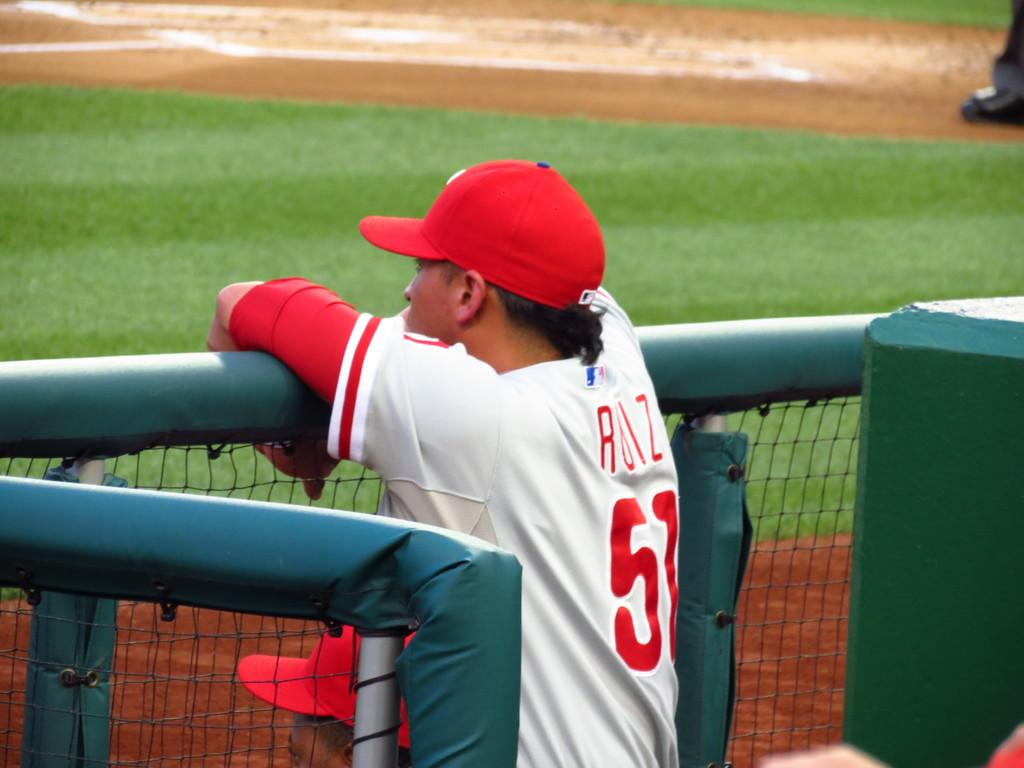<image>
Create a compact narrative representing the image presented. number 51 player is watching the fielding over the fence 